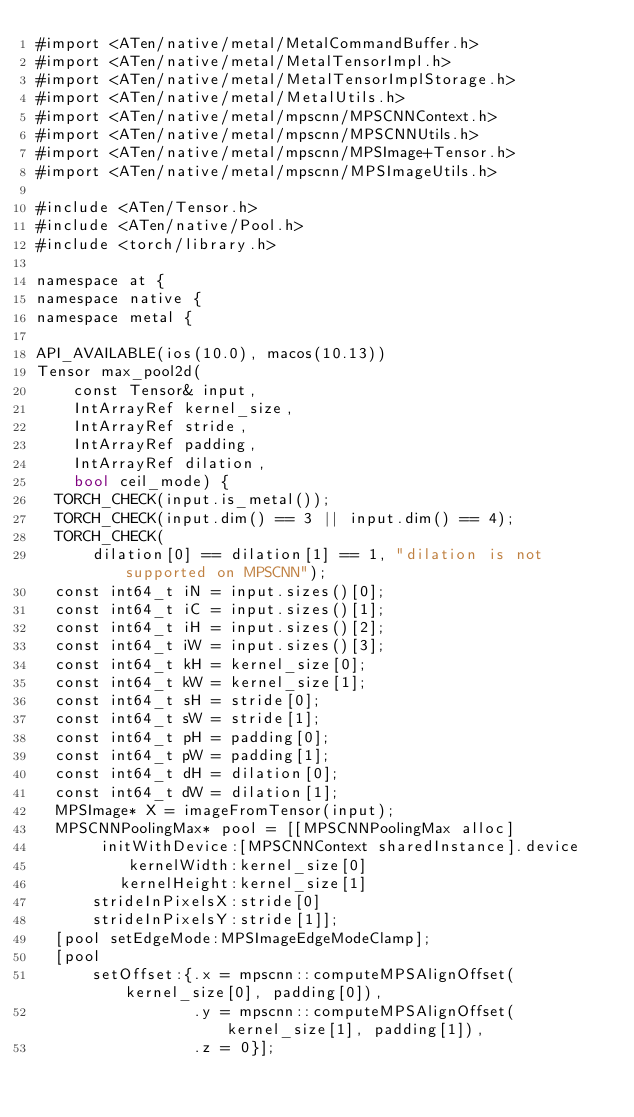Convert code to text. <code><loc_0><loc_0><loc_500><loc_500><_ObjectiveC_>#import <ATen/native/metal/MetalCommandBuffer.h>
#import <ATen/native/metal/MetalTensorImpl.h>
#import <ATen/native/metal/MetalTensorImplStorage.h>
#import <ATen/native/metal/MetalUtils.h>
#import <ATen/native/metal/mpscnn/MPSCNNContext.h>
#import <ATen/native/metal/mpscnn/MPSCNNUtils.h>
#import <ATen/native/metal/mpscnn/MPSImage+Tensor.h>
#import <ATen/native/metal/mpscnn/MPSImageUtils.h>

#include <ATen/Tensor.h>
#include <ATen/native/Pool.h>
#include <torch/library.h>

namespace at {
namespace native {
namespace metal {

API_AVAILABLE(ios(10.0), macos(10.13))
Tensor max_pool2d(
    const Tensor& input,
    IntArrayRef kernel_size,
    IntArrayRef stride,
    IntArrayRef padding,
    IntArrayRef dilation,
    bool ceil_mode) {
  TORCH_CHECK(input.is_metal());
  TORCH_CHECK(input.dim() == 3 || input.dim() == 4);
  TORCH_CHECK(
      dilation[0] == dilation[1] == 1, "dilation is not supported on MPSCNN");
  const int64_t iN = input.sizes()[0];
  const int64_t iC = input.sizes()[1];
  const int64_t iH = input.sizes()[2];
  const int64_t iW = input.sizes()[3];
  const int64_t kH = kernel_size[0];
  const int64_t kW = kernel_size[1];
  const int64_t sH = stride[0];
  const int64_t sW = stride[1];
  const int64_t pH = padding[0];
  const int64_t pW = padding[1];
  const int64_t dH = dilation[0];
  const int64_t dW = dilation[1];
  MPSImage* X = imageFromTensor(input);
  MPSCNNPoolingMax* pool = [[MPSCNNPoolingMax alloc]
       initWithDevice:[MPSCNNContext sharedInstance].device
          kernelWidth:kernel_size[0]
         kernelHeight:kernel_size[1]
      strideInPixelsX:stride[0]
      strideInPixelsY:stride[1]];
  [pool setEdgeMode:MPSImageEdgeModeClamp];
  [pool
      setOffset:{.x = mpscnn::computeMPSAlignOffset(kernel_size[0], padding[0]),
                 .y = mpscnn::computeMPSAlignOffset(kernel_size[1], padding[1]),
                 .z = 0}];</code> 